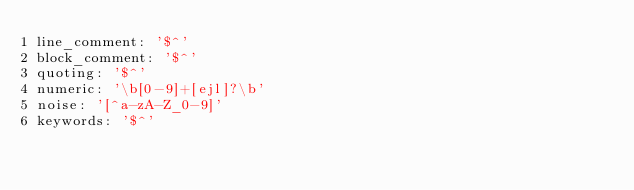<code> <loc_0><loc_0><loc_500><loc_500><_YAML_>line_comment: '$^'
block_comment: '$^'
quoting: '$^'
numeric: '\b[0-9]+[ejl]?\b'
noise: '[^a-zA-Z_0-9]'
keywords: '$^'
</code> 